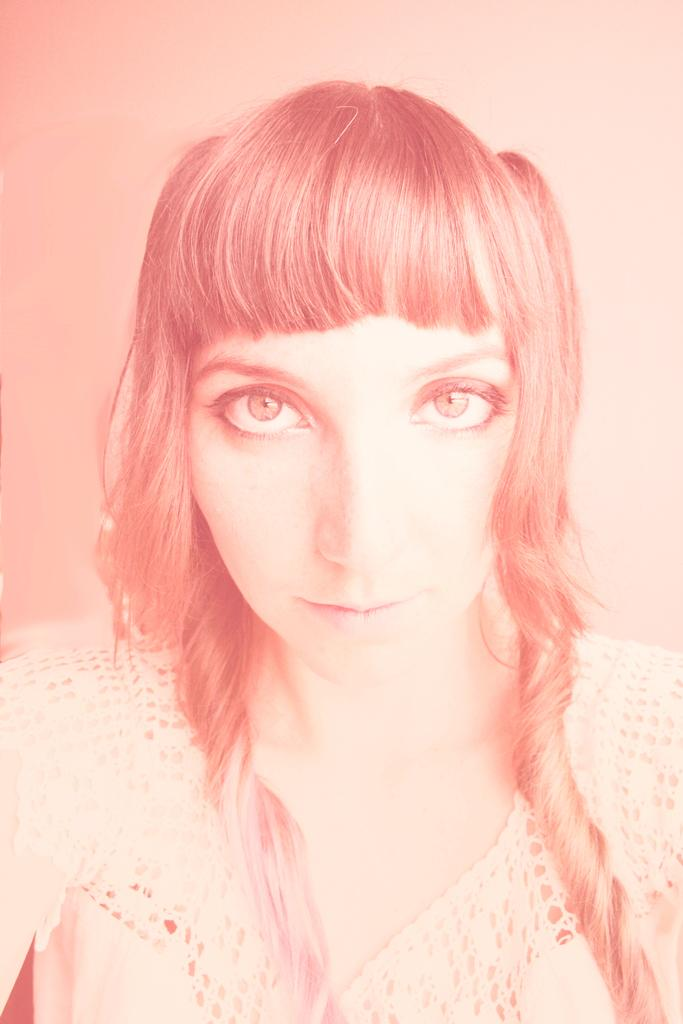Who is the main subject in the image? There is a woman in the image. What color is the background of the image? The background of the image is light pink. How many tickets does the woman have in her hand in the image? There is no mention of tickets in the image, so we cannot determine if the woman has any tickets. 